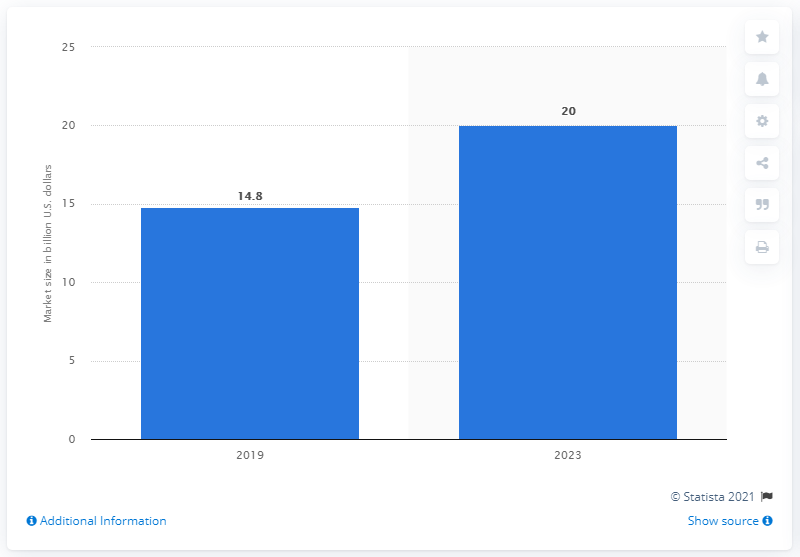Indicate a few pertinent items in this graphic. The e-bike market is expected to generate significant revenue by 2023, with an estimate of $xxx billion. The e-bike market is projected to reach approximately 20 billion U.S. dollars in revenue by the year 2023. 